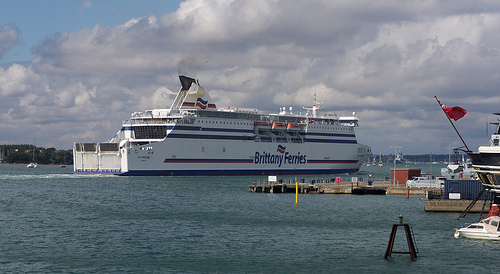Please provide a short description for this region: [0.88, 0.56, 0.98, 0.63]. A blue crate located on the pier. 